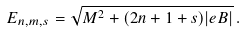Convert formula to latex. <formula><loc_0><loc_0><loc_500><loc_500>E _ { n , m , s } = \sqrt { M ^ { 2 } + ( 2 n + 1 + s ) | e B | } \, .</formula> 